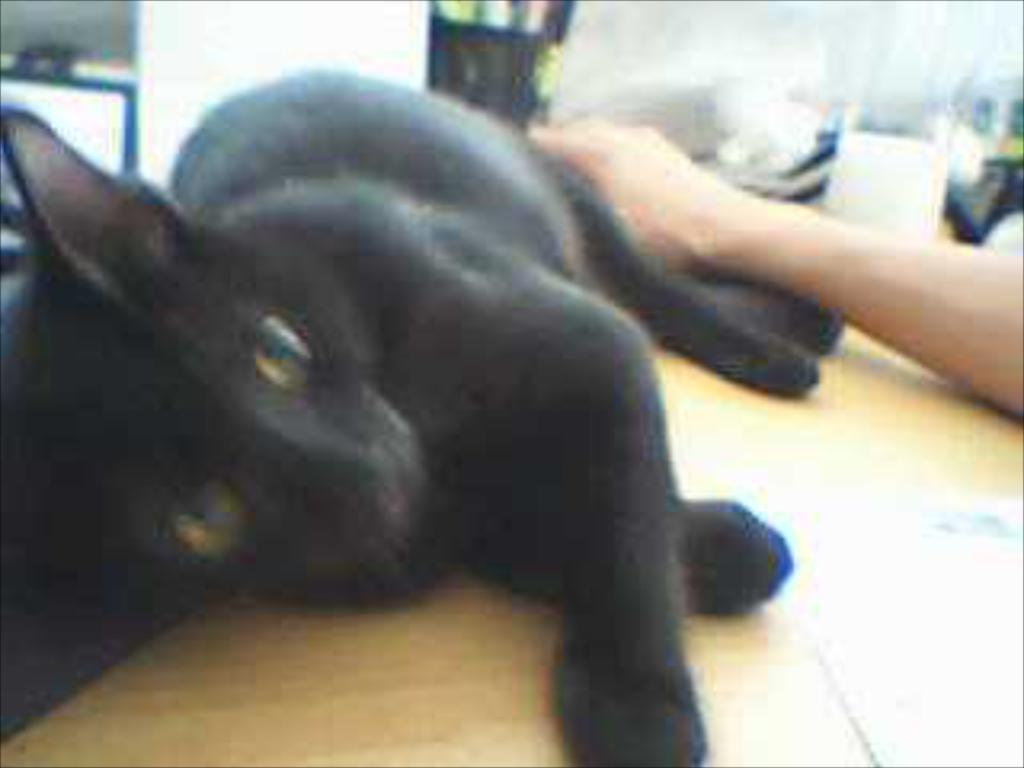What type of animal is in the image? There is a black color cat in the image. Where is the cat located? The cat is on a wooden table. Can you see any human presence in the image? Yes, there is a hand of a person on the right side of the image. What type of trouble is the cat causing in the hospital in the image? There is no hospital or trouble mentioned in the image; it only features a black color cat on a wooden table and a hand of a person. 